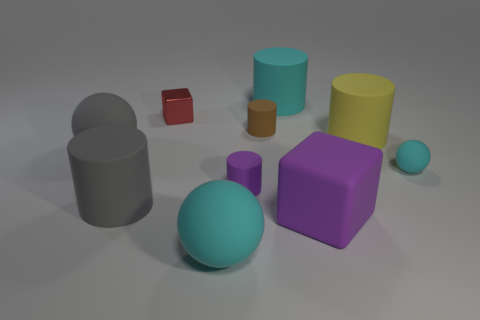Is there a big gray thing that has the same material as the big gray ball?
Provide a succinct answer. Yes. How many objects are small purple objects that are to the left of the purple cube or large green balls?
Give a very brief answer. 1. Are any gray balls visible?
Your answer should be very brief. Yes. What is the shape of the large matte object that is both behind the purple rubber cylinder and on the left side of the tiny block?
Provide a short and direct response. Sphere. How big is the cyan object that is in front of the big purple matte thing?
Provide a succinct answer. Large. There is a cube behind the big gray ball; does it have the same color as the big matte cube?
Your answer should be compact. No. How many large gray objects are the same shape as the small brown thing?
Make the answer very short. 1. What number of objects are either small matte things left of the large cyan cylinder or objects on the left side of the big cube?
Your answer should be very brief. 7. What number of blue things are rubber spheres or rubber objects?
Provide a succinct answer. 0. What is the cyan object that is on the left side of the big yellow rubber thing and in front of the large cyan rubber cylinder made of?
Ensure brevity in your answer.  Rubber. 